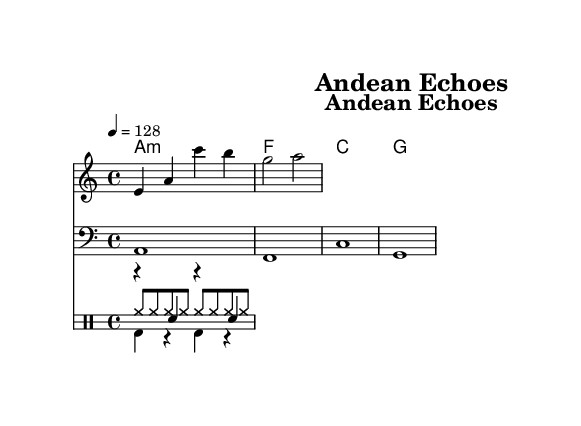What is the key signature of this music? The key signature is indicated by the symbol near the beginning of the sheet music, which shows 'A minor' as it has no sharps or flats.
Answer: A minor What is the time signature of this music? The time signature is determined by the numbers shown following the clef and key signature; it reads '4/4', indicating four beats per measure.
Answer: 4/4 What is the tempo of this piece? The tempo is indicated by the marking stating '4 = 128', which means there are 128 beats per minute, giving a fast pace.
Answer: 128 How many measures are in the melody section? The melody section has been laid out in two measures based on the structure written, which clearly includes notes divided into two segments.
Answer: 2 What is the first lyric phrase of the verse? The first lyric phrase is provided under the melody staff, and it begins with the words 'An -- dean moun -- tains' forming a complete thought.
Answer: An dean mountains What type of drum is used in the kick part? The drum type can be identified in the rhythm section beneath the melody; it reads 'bd', which stands for bass drum, indicating its role in House music.
Answer: Bass drum What is the lyric of the chorus? The chorus lyric is a direct quote from the sheet music which is structured to emphasize the environmental message with the words 'E -- co -- con -- scious, we must be'.
Answer: Eco-conscious, we must be 